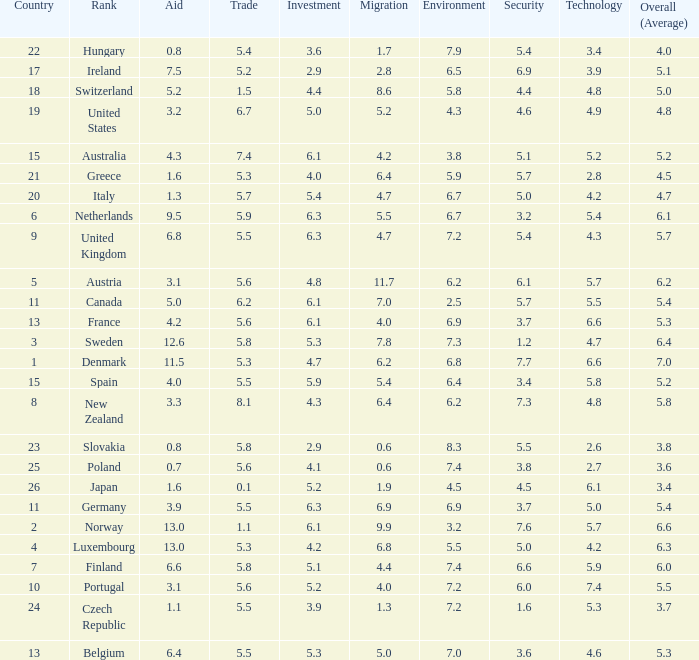What is the environment rating of the country with an overall average rating of 4.7? 6.7. 